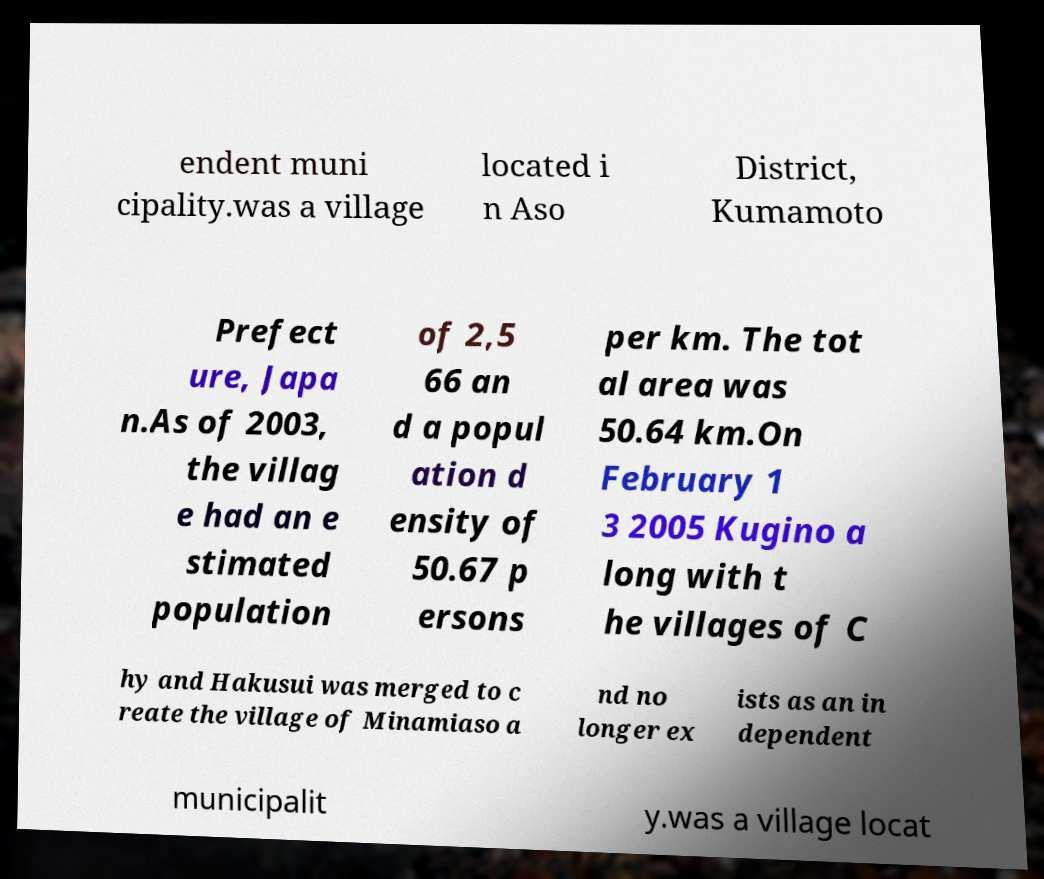I need the written content from this picture converted into text. Can you do that? endent muni cipality.was a village located i n Aso District, Kumamoto Prefect ure, Japa n.As of 2003, the villag e had an e stimated population of 2,5 66 an d a popul ation d ensity of 50.67 p ersons per km. The tot al area was 50.64 km.On February 1 3 2005 Kugino a long with t he villages of C hy and Hakusui was merged to c reate the village of Minamiaso a nd no longer ex ists as an in dependent municipalit y.was a village locat 